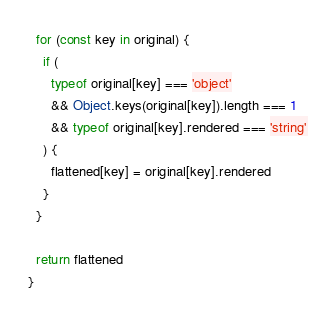<code> <loc_0><loc_0><loc_500><loc_500><_JavaScript_>
  for (const key in original) {
    if (
      typeof original[key] === 'object'
      && Object.keys(original[key]).length === 1
      && typeof original[key].rendered === 'string'
    ) {
      flattened[key] = original[key].rendered
    }
  }

  return flattened
}
</code> 